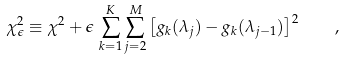Convert formula to latex. <formula><loc_0><loc_0><loc_500><loc_500>\chi _ { \epsilon } ^ { 2 } \equiv \chi ^ { 2 } + \epsilon \, \sum _ { k = 1 } ^ { K } \sum _ { j = 2 } ^ { M } \left [ g _ { k } ( \lambda _ { j } ) - g _ { k } ( \lambda _ { j - 1 } ) \right ] ^ { 2 } \quad ,</formula> 